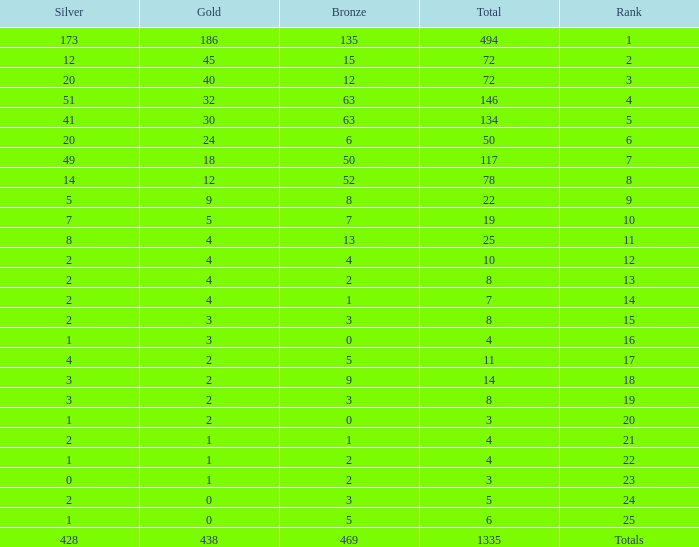Parse the full table. {'header': ['Silver', 'Gold', 'Bronze', 'Total', 'Rank'], 'rows': [['173', '186', '135', '494', '1'], ['12', '45', '15', '72', '2'], ['20', '40', '12', '72', '3'], ['51', '32', '63', '146', '4'], ['41', '30', '63', '134', '5'], ['20', '24', '6', '50', '6'], ['49', '18', '50', '117', '7'], ['14', '12', '52', '78', '8'], ['5', '9', '8', '22', '9'], ['7', '5', '7', '19', '10'], ['8', '4', '13', '25', '11'], ['2', '4', '4', '10', '12'], ['2', '4', '2', '8', '13'], ['2', '4', '1', '7', '14'], ['2', '3', '3', '8', '15'], ['1', '3', '0', '4', '16'], ['4', '2', '5', '11', '17'], ['3', '2', '9', '14', '18'], ['3', '2', '3', '8', '19'], ['1', '2', '0', '3', '20'], ['2', '1', '1', '4', '21'], ['1', '1', '2', '4', '22'], ['0', '1', '2', '3', '23'], ['2', '0', '3', '5', '24'], ['1', '0', '5', '6', '25'], ['428', '438', '469', '1335', 'Totals']]} What is the total amount of gold medals when there were more than 20 silvers and there were 135 bronze medals? 1.0. 